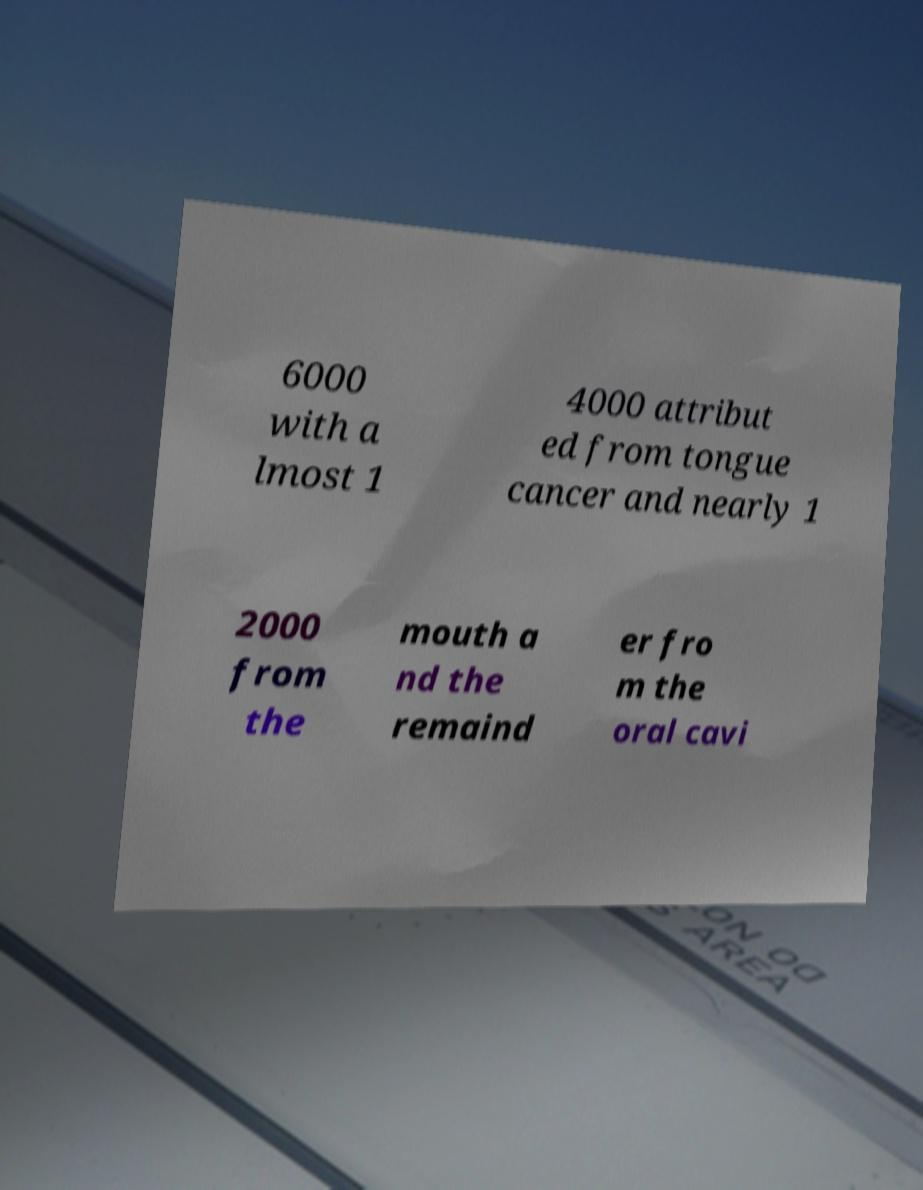Could you assist in decoding the text presented in this image and type it out clearly? 6000 with a lmost 1 4000 attribut ed from tongue cancer and nearly 1 2000 from the mouth a nd the remaind er fro m the oral cavi 